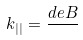Convert formula to latex. <formula><loc_0><loc_0><loc_500><loc_500>k _ { | | } = \frac { d e B } { }</formula> 